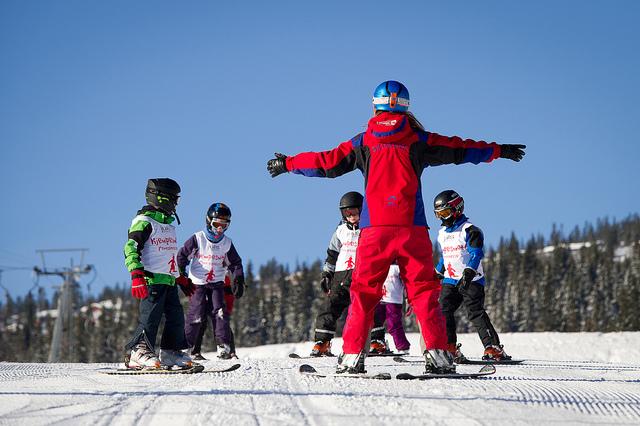Who are skiing?
Give a very brief answer. Children. How many skiers do you see?
Keep it brief. 6. Do any of them have ski poles?
Short answer required. No. 